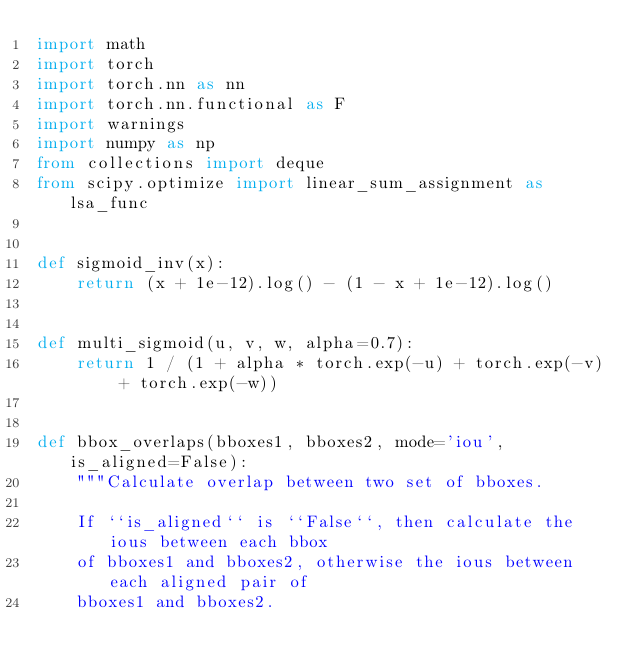Convert code to text. <code><loc_0><loc_0><loc_500><loc_500><_Python_>import math
import torch
import torch.nn as nn
import torch.nn.functional as F
import warnings
import numpy as np
from collections import deque
from scipy.optimize import linear_sum_assignment as lsa_func


def sigmoid_inv(x):
    return (x + 1e-12).log() - (1 - x + 1e-12).log()


def multi_sigmoid(u, v, w, alpha=0.7):
    return 1 / (1 + alpha * torch.exp(-u) + torch.exp(-v) + torch.exp(-w))


def bbox_overlaps(bboxes1, bboxes2, mode='iou', is_aligned=False):
    """Calculate overlap between two set of bboxes.

    If ``is_aligned`` is ``False``, then calculate the ious between each bbox
    of bboxes1 and bboxes2, otherwise the ious between each aligned pair of
    bboxes1 and bboxes2.
</code> 